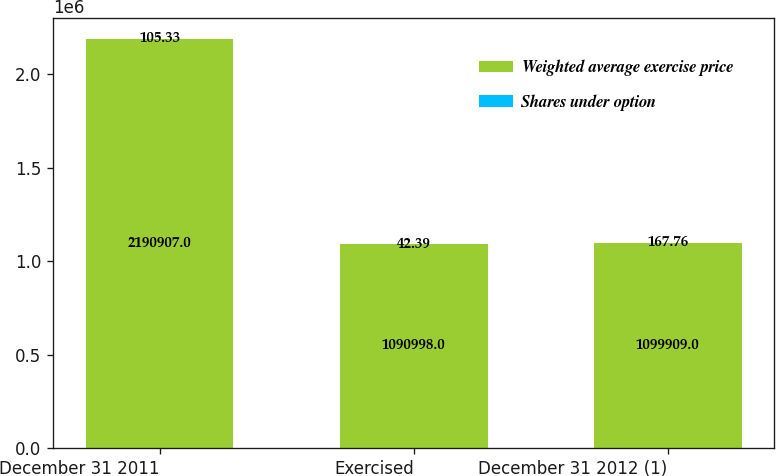Convert chart to OTSL. <chart><loc_0><loc_0><loc_500><loc_500><stacked_bar_chart><ecel><fcel>December 31 2011<fcel>Exercised<fcel>December 31 2012 (1)<nl><fcel>Weighted average exercise price<fcel>2.19091e+06<fcel>1.091e+06<fcel>1.09991e+06<nl><fcel>Shares under option<fcel>105.33<fcel>42.39<fcel>167.76<nl></chart> 